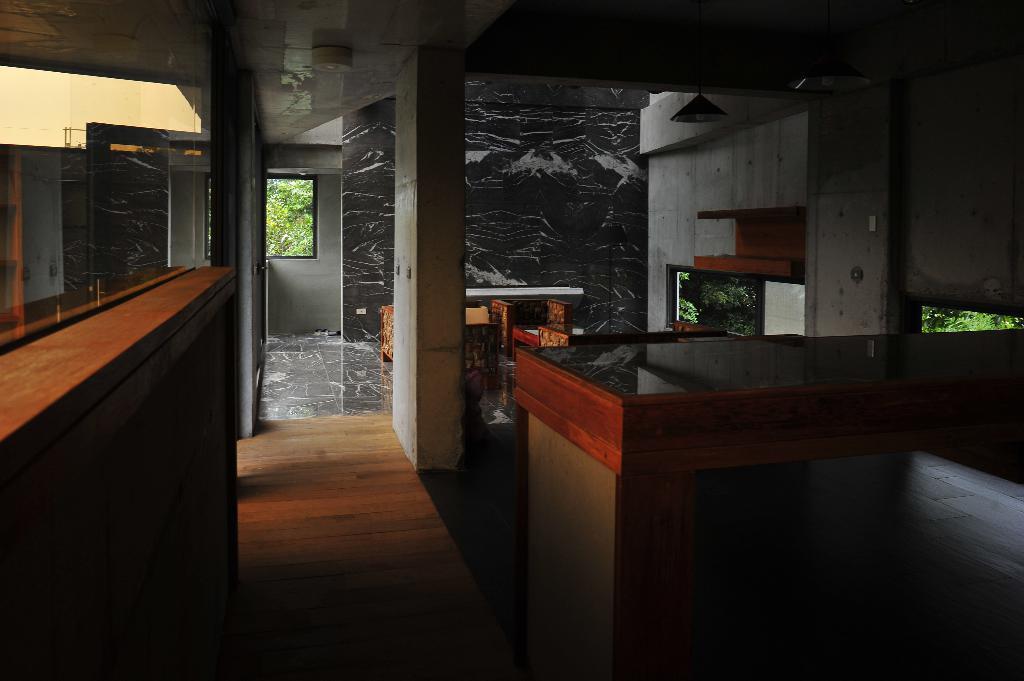Could you give a brief overview of what you see in this image? In the foreground of this image, there is floor. On the left, there is a wooden object. On the right, there is a table. We can also see a pillar, wall, windows and a light. In the background, there is greenery. 